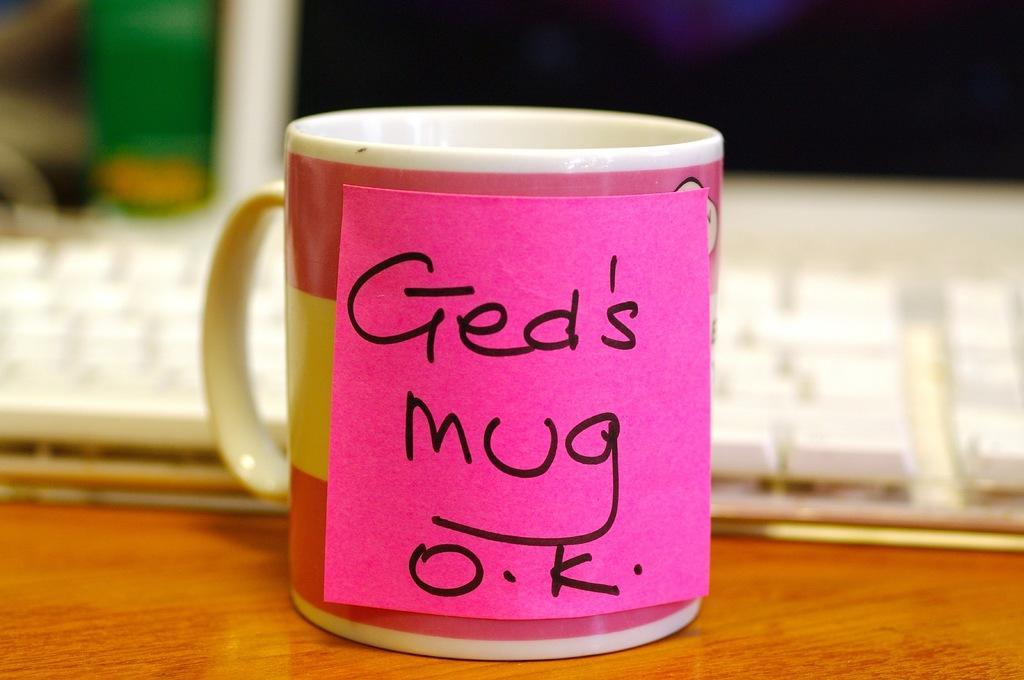<image>
Write a terse but informative summary of the picture. A coffee mug on an office desk with the words "Ged's mug O.K" written on a sticky note attached to it. 